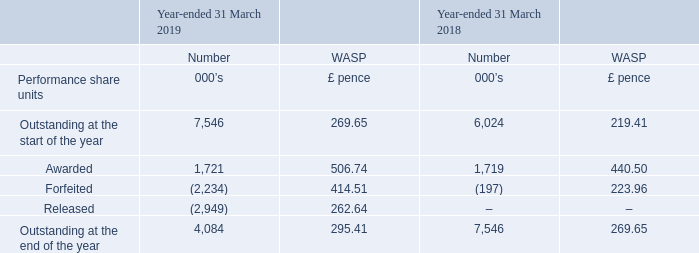Performance Share Units
The following table illustrates the number and WASP on date of award, and movements in, performance share units (“PSUs”) granted under the 2015 LTIP:
PSUs vest on one vesting date following a three year vesting period which will comprise three financial years. The awards are divided into three equal parts which will each be subject to a separate annual performance condition linked to the financial performance of the Group.
What is the  Outstanding at the start of the year  for 2019?
Answer scale should be: thousand. 7,546. Why are the PSU awards divided into three equal parts? The awards are divided into three equal parts which will each be subject to a separate annual performance condition linked to the financial performance of the group. What are the types of movements in performance share units (“PSUs”) illustrated in the table? Awarded, forfeited, released. In which year was the number of PSUs awarded larger? 1,721>1,719
Answer: 2019. What was the change in the number of PSUs outstanding at the end of the year in 2019 from 2018?
Answer scale should be: thousand. 4,084-7,546
Answer: -3462. What was the percentage change in the number of PSUs outstanding at the end of the year in 2019 from 2018?
Answer scale should be: percent. (4,084-7,546)/7,546
Answer: -45.88. 